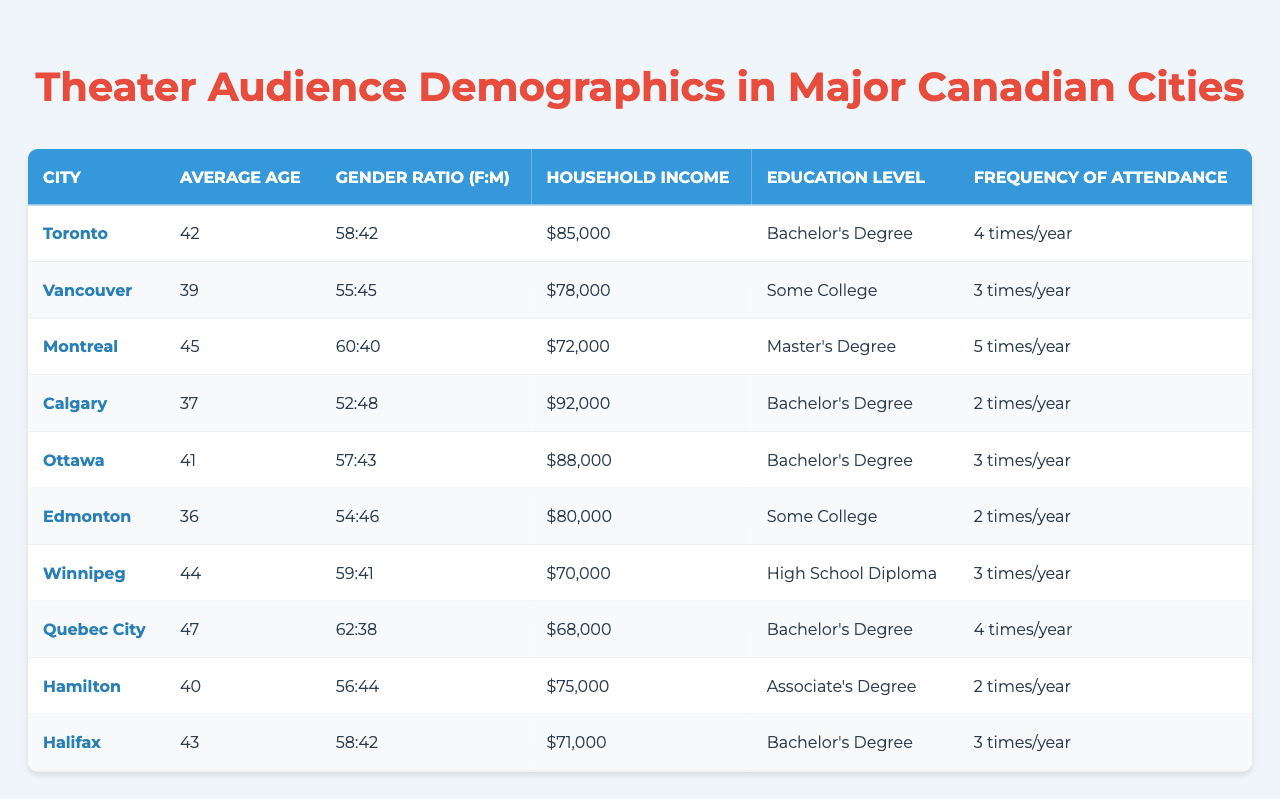What is the average age of theater audiences in Montreal? The table indicates that the average age of theater audiences in Montreal is specifically listed under the "Average Age" column. Looking at the row for Montreal, the value is 45.
Answer: 45 Which city has the highest household income among the listed cities? By examining the "Household Income" column, we can see the figures listed for each city. Toronto has $85,000, Calgary has $92,000, and Ottawa has $88,000. Since Calgary has the highest income at $92,000, it is the answer.
Answer: Calgary Do more women than men attend theater in Vancouver? The gender ratio for Vancouver is given as 55:45. Since 55 represents women and 45 represents men, more women attend than men.
Answer: Yes What is the frequency of attendance in Halifax? The "Frequency of Attendance" column indicates how often audiences attend theater in Halifax, which is stated as 3 times a year.
Answer: 3 times/year What is the average age of audiences in the cities listed? To find the average age, we sum all the average ages: (42 + 39 + 45 + 37 + 41 + 36 + 44 + 47 + 40 + 43) = 414. There are 10 cities, so we divide by 10: 414 / 10 = 41.4. Therefore, the average age is approximately 41.4.
Answer: 41.4 Is the education level of the theater audiences in Calgary higher than that in Edmonton? For Calgary, the education level is listed as "Bachelor's Degree". In Edmonton, it is "Some College". A Bachelor's Degree is higher than Some College, so the answer is yes.
Answer: Yes What is the combined frequency of attendance for both Toronto and Quebec City? Looking at the frequency of attendance, Toronto has 4 times a year and Quebec City also has 4 times a year. Adding these together gives: 4 + 4 = 8 times a year as their combined frequency of attendance.
Answer: 8 times/year Which city has the lowest percentage of male attendees based on the gender ratio? To determine this, we look at the gender ratio for each city. Montreal has the ratio of 60:40, which means 40% men, and Winnipeg has a ratio of 59:41, meaning 41% men. Comparing all the cities, Montreal has the lowest percentage of male attendees at 40%.
Answer: Montreal What is the median household income among the listed cities? To find the median, we must list the household incomes in ascending order: $68,000, $70,000, $72,000, $75,000, $78,000, $80,000, $85,000, $88,000, $92,000. The median is the average of the 5th and 6th prices: ($78,000 + $80,000) / 2 = $79,000.
Answer: $79,000 Which city's audience has the highest educational achievement? The highest educational attainment in the education levels listed is a "Master's Degree", which is specific to Montreal. Therefore, Montreal has the highest educational achievement among these cities.
Answer: Montreal 